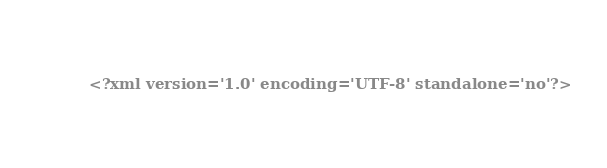Convert code to text. <code><loc_0><loc_0><loc_500><loc_500><_XML_><?xml version='1.0' encoding='UTF-8' standalone='no'?></code> 